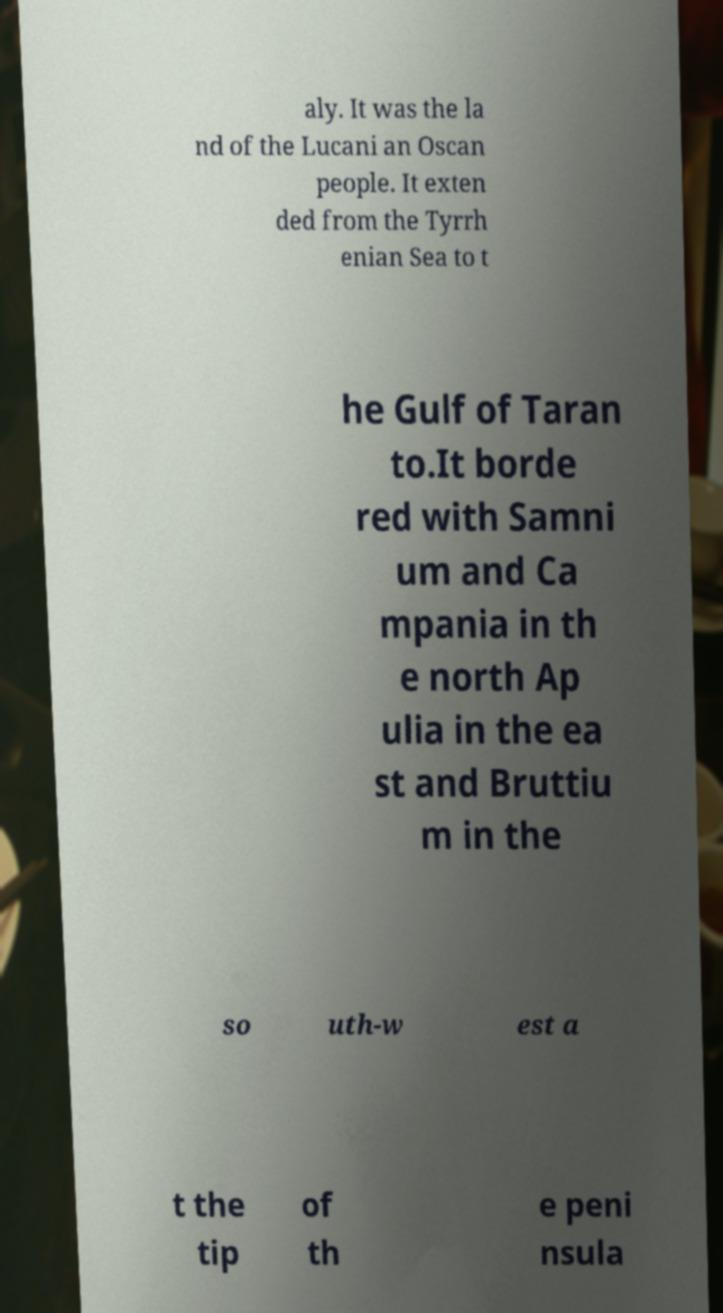Can you read and provide the text displayed in the image?This photo seems to have some interesting text. Can you extract and type it out for me? aly. It was the la nd of the Lucani an Oscan people. It exten ded from the Tyrrh enian Sea to t he Gulf of Taran to.It borde red with Samni um and Ca mpania in th e north Ap ulia in the ea st and Bruttiu m in the so uth-w est a t the tip of th e peni nsula 